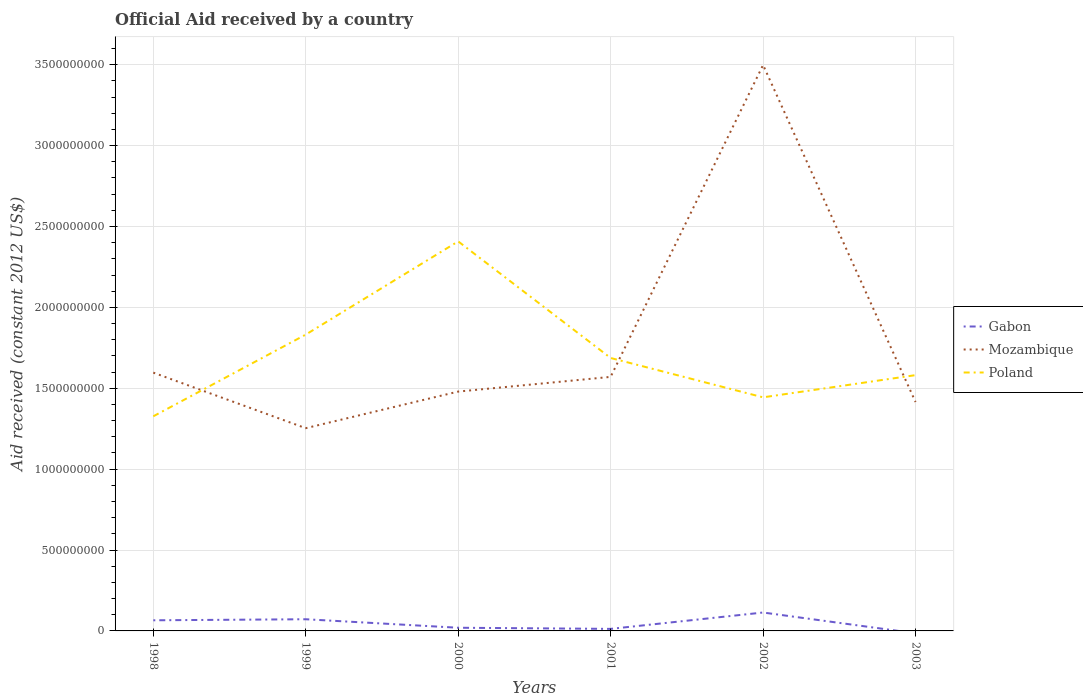Does the line corresponding to Gabon intersect with the line corresponding to Mozambique?
Give a very brief answer. No. Is the number of lines equal to the number of legend labels?
Ensure brevity in your answer.  No. Across all years, what is the maximum net official aid received in Poland?
Ensure brevity in your answer.  1.33e+09. What is the total net official aid received in Mozambique in the graph?
Your answer should be very brief. -1.90e+09. What is the difference between the highest and the second highest net official aid received in Gabon?
Ensure brevity in your answer.  1.14e+08. What is the difference between the highest and the lowest net official aid received in Poland?
Provide a succinct answer. 2. How many years are there in the graph?
Keep it short and to the point. 6. What is the difference between two consecutive major ticks on the Y-axis?
Ensure brevity in your answer.  5.00e+08. Are the values on the major ticks of Y-axis written in scientific E-notation?
Keep it short and to the point. No. Does the graph contain grids?
Provide a succinct answer. Yes. Where does the legend appear in the graph?
Offer a very short reply. Center right. What is the title of the graph?
Make the answer very short. Official Aid received by a country. What is the label or title of the X-axis?
Ensure brevity in your answer.  Years. What is the label or title of the Y-axis?
Make the answer very short. Aid received (constant 2012 US$). What is the Aid received (constant 2012 US$) in Gabon in 1998?
Your response must be concise. 6.57e+07. What is the Aid received (constant 2012 US$) of Mozambique in 1998?
Your answer should be very brief. 1.60e+09. What is the Aid received (constant 2012 US$) of Poland in 1998?
Offer a terse response. 1.33e+09. What is the Aid received (constant 2012 US$) of Gabon in 1999?
Keep it short and to the point. 7.22e+07. What is the Aid received (constant 2012 US$) of Mozambique in 1999?
Ensure brevity in your answer.  1.25e+09. What is the Aid received (constant 2012 US$) in Poland in 1999?
Your answer should be compact. 1.83e+09. What is the Aid received (constant 2012 US$) of Gabon in 2000?
Provide a short and direct response. 1.96e+07. What is the Aid received (constant 2012 US$) in Mozambique in 2000?
Give a very brief answer. 1.48e+09. What is the Aid received (constant 2012 US$) in Poland in 2000?
Your response must be concise. 2.41e+09. What is the Aid received (constant 2012 US$) of Gabon in 2001?
Provide a succinct answer. 1.26e+07. What is the Aid received (constant 2012 US$) in Mozambique in 2001?
Your answer should be very brief. 1.57e+09. What is the Aid received (constant 2012 US$) of Poland in 2001?
Your answer should be compact. 1.69e+09. What is the Aid received (constant 2012 US$) of Gabon in 2002?
Your answer should be very brief. 1.14e+08. What is the Aid received (constant 2012 US$) of Mozambique in 2002?
Offer a very short reply. 3.50e+09. What is the Aid received (constant 2012 US$) of Poland in 2002?
Ensure brevity in your answer.  1.44e+09. What is the Aid received (constant 2012 US$) of Mozambique in 2003?
Keep it short and to the point. 1.42e+09. What is the Aid received (constant 2012 US$) in Poland in 2003?
Your answer should be compact. 1.58e+09. Across all years, what is the maximum Aid received (constant 2012 US$) of Gabon?
Provide a short and direct response. 1.14e+08. Across all years, what is the maximum Aid received (constant 2012 US$) in Mozambique?
Give a very brief answer. 3.50e+09. Across all years, what is the maximum Aid received (constant 2012 US$) of Poland?
Ensure brevity in your answer.  2.41e+09. Across all years, what is the minimum Aid received (constant 2012 US$) in Gabon?
Provide a succinct answer. 0. Across all years, what is the minimum Aid received (constant 2012 US$) in Mozambique?
Your response must be concise. 1.25e+09. Across all years, what is the minimum Aid received (constant 2012 US$) in Poland?
Keep it short and to the point. 1.33e+09. What is the total Aid received (constant 2012 US$) in Gabon in the graph?
Offer a very short reply. 2.84e+08. What is the total Aid received (constant 2012 US$) of Mozambique in the graph?
Keep it short and to the point. 1.08e+1. What is the total Aid received (constant 2012 US$) in Poland in the graph?
Your answer should be compact. 1.03e+1. What is the difference between the Aid received (constant 2012 US$) in Gabon in 1998 and that in 1999?
Give a very brief answer. -6.49e+06. What is the difference between the Aid received (constant 2012 US$) of Mozambique in 1998 and that in 1999?
Provide a short and direct response. 3.43e+08. What is the difference between the Aid received (constant 2012 US$) of Poland in 1998 and that in 1999?
Your answer should be very brief. -5.05e+08. What is the difference between the Aid received (constant 2012 US$) of Gabon in 1998 and that in 2000?
Provide a succinct answer. 4.61e+07. What is the difference between the Aid received (constant 2012 US$) of Mozambique in 1998 and that in 2000?
Offer a terse response. 1.17e+08. What is the difference between the Aid received (constant 2012 US$) in Poland in 1998 and that in 2000?
Provide a succinct answer. -1.08e+09. What is the difference between the Aid received (constant 2012 US$) of Gabon in 1998 and that in 2001?
Provide a succinct answer. 5.31e+07. What is the difference between the Aid received (constant 2012 US$) in Mozambique in 1998 and that in 2001?
Your answer should be compact. 2.62e+07. What is the difference between the Aid received (constant 2012 US$) in Poland in 1998 and that in 2001?
Give a very brief answer. -3.60e+08. What is the difference between the Aid received (constant 2012 US$) of Gabon in 1998 and that in 2002?
Your response must be concise. -4.81e+07. What is the difference between the Aid received (constant 2012 US$) in Mozambique in 1998 and that in 2002?
Your answer should be compact. -1.90e+09. What is the difference between the Aid received (constant 2012 US$) in Poland in 1998 and that in 2002?
Provide a succinct answer. -1.17e+08. What is the difference between the Aid received (constant 2012 US$) in Mozambique in 1998 and that in 2003?
Make the answer very short. 1.82e+08. What is the difference between the Aid received (constant 2012 US$) of Poland in 1998 and that in 2003?
Keep it short and to the point. -2.55e+08. What is the difference between the Aid received (constant 2012 US$) of Gabon in 1999 and that in 2000?
Provide a short and direct response. 5.26e+07. What is the difference between the Aid received (constant 2012 US$) in Mozambique in 1999 and that in 2000?
Give a very brief answer. -2.26e+08. What is the difference between the Aid received (constant 2012 US$) in Poland in 1999 and that in 2000?
Offer a very short reply. -5.76e+08. What is the difference between the Aid received (constant 2012 US$) in Gabon in 1999 and that in 2001?
Offer a terse response. 5.96e+07. What is the difference between the Aid received (constant 2012 US$) of Mozambique in 1999 and that in 2001?
Give a very brief answer. -3.17e+08. What is the difference between the Aid received (constant 2012 US$) in Poland in 1999 and that in 2001?
Your answer should be very brief. 1.45e+08. What is the difference between the Aid received (constant 2012 US$) in Gabon in 1999 and that in 2002?
Provide a succinct answer. -4.16e+07. What is the difference between the Aid received (constant 2012 US$) of Mozambique in 1999 and that in 2002?
Your answer should be very brief. -2.25e+09. What is the difference between the Aid received (constant 2012 US$) in Poland in 1999 and that in 2002?
Give a very brief answer. 3.88e+08. What is the difference between the Aid received (constant 2012 US$) in Mozambique in 1999 and that in 2003?
Give a very brief answer. -1.62e+08. What is the difference between the Aid received (constant 2012 US$) of Poland in 1999 and that in 2003?
Provide a succinct answer. 2.51e+08. What is the difference between the Aid received (constant 2012 US$) of Mozambique in 2000 and that in 2001?
Provide a succinct answer. -9.08e+07. What is the difference between the Aid received (constant 2012 US$) of Poland in 2000 and that in 2001?
Provide a short and direct response. 7.21e+08. What is the difference between the Aid received (constant 2012 US$) of Gabon in 2000 and that in 2002?
Make the answer very short. -9.42e+07. What is the difference between the Aid received (constant 2012 US$) of Mozambique in 2000 and that in 2002?
Provide a succinct answer. -2.02e+09. What is the difference between the Aid received (constant 2012 US$) of Poland in 2000 and that in 2002?
Give a very brief answer. 9.64e+08. What is the difference between the Aid received (constant 2012 US$) of Mozambique in 2000 and that in 2003?
Ensure brevity in your answer.  6.45e+07. What is the difference between the Aid received (constant 2012 US$) of Poland in 2000 and that in 2003?
Your response must be concise. 8.27e+08. What is the difference between the Aid received (constant 2012 US$) in Gabon in 2001 and that in 2002?
Make the answer very short. -1.01e+08. What is the difference between the Aid received (constant 2012 US$) in Mozambique in 2001 and that in 2002?
Offer a terse response. -1.93e+09. What is the difference between the Aid received (constant 2012 US$) of Poland in 2001 and that in 2002?
Give a very brief answer. 2.43e+08. What is the difference between the Aid received (constant 2012 US$) in Mozambique in 2001 and that in 2003?
Your answer should be compact. 1.55e+08. What is the difference between the Aid received (constant 2012 US$) of Poland in 2001 and that in 2003?
Offer a terse response. 1.06e+08. What is the difference between the Aid received (constant 2012 US$) of Mozambique in 2002 and that in 2003?
Your answer should be compact. 2.08e+09. What is the difference between the Aid received (constant 2012 US$) of Poland in 2002 and that in 2003?
Give a very brief answer. -1.37e+08. What is the difference between the Aid received (constant 2012 US$) in Gabon in 1998 and the Aid received (constant 2012 US$) in Mozambique in 1999?
Offer a terse response. -1.19e+09. What is the difference between the Aid received (constant 2012 US$) of Gabon in 1998 and the Aid received (constant 2012 US$) of Poland in 1999?
Your response must be concise. -1.77e+09. What is the difference between the Aid received (constant 2012 US$) of Mozambique in 1998 and the Aid received (constant 2012 US$) of Poland in 1999?
Your response must be concise. -2.35e+08. What is the difference between the Aid received (constant 2012 US$) of Gabon in 1998 and the Aid received (constant 2012 US$) of Mozambique in 2000?
Your answer should be compact. -1.41e+09. What is the difference between the Aid received (constant 2012 US$) of Gabon in 1998 and the Aid received (constant 2012 US$) of Poland in 2000?
Offer a very short reply. -2.34e+09. What is the difference between the Aid received (constant 2012 US$) in Mozambique in 1998 and the Aid received (constant 2012 US$) in Poland in 2000?
Offer a very short reply. -8.11e+08. What is the difference between the Aid received (constant 2012 US$) of Gabon in 1998 and the Aid received (constant 2012 US$) of Mozambique in 2001?
Provide a succinct answer. -1.50e+09. What is the difference between the Aid received (constant 2012 US$) of Gabon in 1998 and the Aid received (constant 2012 US$) of Poland in 2001?
Your answer should be very brief. -1.62e+09. What is the difference between the Aid received (constant 2012 US$) in Mozambique in 1998 and the Aid received (constant 2012 US$) in Poland in 2001?
Keep it short and to the point. -9.05e+07. What is the difference between the Aid received (constant 2012 US$) in Gabon in 1998 and the Aid received (constant 2012 US$) in Mozambique in 2002?
Ensure brevity in your answer.  -3.43e+09. What is the difference between the Aid received (constant 2012 US$) in Gabon in 1998 and the Aid received (constant 2012 US$) in Poland in 2002?
Ensure brevity in your answer.  -1.38e+09. What is the difference between the Aid received (constant 2012 US$) in Mozambique in 1998 and the Aid received (constant 2012 US$) in Poland in 2002?
Give a very brief answer. 1.53e+08. What is the difference between the Aid received (constant 2012 US$) in Gabon in 1998 and the Aid received (constant 2012 US$) in Mozambique in 2003?
Offer a very short reply. -1.35e+09. What is the difference between the Aid received (constant 2012 US$) in Gabon in 1998 and the Aid received (constant 2012 US$) in Poland in 2003?
Keep it short and to the point. -1.52e+09. What is the difference between the Aid received (constant 2012 US$) of Mozambique in 1998 and the Aid received (constant 2012 US$) of Poland in 2003?
Your answer should be very brief. 1.54e+07. What is the difference between the Aid received (constant 2012 US$) of Gabon in 1999 and the Aid received (constant 2012 US$) of Mozambique in 2000?
Offer a very short reply. -1.41e+09. What is the difference between the Aid received (constant 2012 US$) in Gabon in 1999 and the Aid received (constant 2012 US$) in Poland in 2000?
Ensure brevity in your answer.  -2.34e+09. What is the difference between the Aid received (constant 2012 US$) of Mozambique in 1999 and the Aid received (constant 2012 US$) of Poland in 2000?
Your answer should be very brief. -1.15e+09. What is the difference between the Aid received (constant 2012 US$) in Gabon in 1999 and the Aid received (constant 2012 US$) in Mozambique in 2001?
Provide a short and direct response. -1.50e+09. What is the difference between the Aid received (constant 2012 US$) in Gabon in 1999 and the Aid received (constant 2012 US$) in Poland in 2001?
Offer a terse response. -1.61e+09. What is the difference between the Aid received (constant 2012 US$) in Mozambique in 1999 and the Aid received (constant 2012 US$) in Poland in 2001?
Offer a terse response. -4.34e+08. What is the difference between the Aid received (constant 2012 US$) of Gabon in 1999 and the Aid received (constant 2012 US$) of Mozambique in 2002?
Provide a succinct answer. -3.43e+09. What is the difference between the Aid received (constant 2012 US$) of Gabon in 1999 and the Aid received (constant 2012 US$) of Poland in 2002?
Your answer should be compact. -1.37e+09. What is the difference between the Aid received (constant 2012 US$) of Mozambique in 1999 and the Aid received (constant 2012 US$) of Poland in 2002?
Make the answer very short. -1.91e+08. What is the difference between the Aid received (constant 2012 US$) in Gabon in 1999 and the Aid received (constant 2012 US$) in Mozambique in 2003?
Offer a very short reply. -1.34e+09. What is the difference between the Aid received (constant 2012 US$) of Gabon in 1999 and the Aid received (constant 2012 US$) of Poland in 2003?
Give a very brief answer. -1.51e+09. What is the difference between the Aid received (constant 2012 US$) in Mozambique in 1999 and the Aid received (constant 2012 US$) in Poland in 2003?
Offer a very short reply. -3.28e+08. What is the difference between the Aid received (constant 2012 US$) in Gabon in 2000 and the Aid received (constant 2012 US$) in Mozambique in 2001?
Provide a short and direct response. -1.55e+09. What is the difference between the Aid received (constant 2012 US$) in Gabon in 2000 and the Aid received (constant 2012 US$) in Poland in 2001?
Your answer should be compact. -1.67e+09. What is the difference between the Aid received (constant 2012 US$) in Mozambique in 2000 and the Aid received (constant 2012 US$) in Poland in 2001?
Your answer should be very brief. -2.08e+08. What is the difference between the Aid received (constant 2012 US$) in Gabon in 2000 and the Aid received (constant 2012 US$) in Mozambique in 2002?
Make the answer very short. -3.48e+09. What is the difference between the Aid received (constant 2012 US$) in Gabon in 2000 and the Aid received (constant 2012 US$) in Poland in 2002?
Your answer should be very brief. -1.42e+09. What is the difference between the Aid received (constant 2012 US$) of Mozambique in 2000 and the Aid received (constant 2012 US$) of Poland in 2002?
Your answer should be very brief. 3.56e+07. What is the difference between the Aid received (constant 2012 US$) of Gabon in 2000 and the Aid received (constant 2012 US$) of Mozambique in 2003?
Provide a short and direct response. -1.40e+09. What is the difference between the Aid received (constant 2012 US$) of Gabon in 2000 and the Aid received (constant 2012 US$) of Poland in 2003?
Provide a short and direct response. -1.56e+09. What is the difference between the Aid received (constant 2012 US$) in Mozambique in 2000 and the Aid received (constant 2012 US$) in Poland in 2003?
Your response must be concise. -1.02e+08. What is the difference between the Aid received (constant 2012 US$) of Gabon in 2001 and the Aid received (constant 2012 US$) of Mozambique in 2002?
Offer a terse response. -3.49e+09. What is the difference between the Aid received (constant 2012 US$) of Gabon in 2001 and the Aid received (constant 2012 US$) of Poland in 2002?
Provide a short and direct response. -1.43e+09. What is the difference between the Aid received (constant 2012 US$) in Mozambique in 2001 and the Aid received (constant 2012 US$) in Poland in 2002?
Ensure brevity in your answer.  1.26e+08. What is the difference between the Aid received (constant 2012 US$) of Gabon in 2001 and the Aid received (constant 2012 US$) of Mozambique in 2003?
Make the answer very short. -1.40e+09. What is the difference between the Aid received (constant 2012 US$) in Gabon in 2001 and the Aid received (constant 2012 US$) in Poland in 2003?
Your answer should be very brief. -1.57e+09. What is the difference between the Aid received (constant 2012 US$) in Mozambique in 2001 and the Aid received (constant 2012 US$) in Poland in 2003?
Give a very brief answer. -1.08e+07. What is the difference between the Aid received (constant 2012 US$) in Gabon in 2002 and the Aid received (constant 2012 US$) in Mozambique in 2003?
Your response must be concise. -1.30e+09. What is the difference between the Aid received (constant 2012 US$) of Gabon in 2002 and the Aid received (constant 2012 US$) of Poland in 2003?
Your answer should be compact. -1.47e+09. What is the difference between the Aid received (constant 2012 US$) of Mozambique in 2002 and the Aid received (constant 2012 US$) of Poland in 2003?
Offer a very short reply. 1.92e+09. What is the average Aid received (constant 2012 US$) of Gabon per year?
Provide a short and direct response. 4.73e+07. What is the average Aid received (constant 2012 US$) of Mozambique per year?
Your response must be concise. 1.80e+09. What is the average Aid received (constant 2012 US$) in Poland per year?
Your answer should be compact. 1.71e+09. In the year 1998, what is the difference between the Aid received (constant 2012 US$) in Gabon and Aid received (constant 2012 US$) in Mozambique?
Offer a very short reply. -1.53e+09. In the year 1998, what is the difference between the Aid received (constant 2012 US$) in Gabon and Aid received (constant 2012 US$) in Poland?
Provide a short and direct response. -1.26e+09. In the year 1998, what is the difference between the Aid received (constant 2012 US$) of Mozambique and Aid received (constant 2012 US$) of Poland?
Ensure brevity in your answer.  2.70e+08. In the year 1999, what is the difference between the Aid received (constant 2012 US$) in Gabon and Aid received (constant 2012 US$) in Mozambique?
Provide a succinct answer. -1.18e+09. In the year 1999, what is the difference between the Aid received (constant 2012 US$) of Gabon and Aid received (constant 2012 US$) of Poland?
Provide a succinct answer. -1.76e+09. In the year 1999, what is the difference between the Aid received (constant 2012 US$) of Mozambique and Aid received (constant 2012 US$) of Poland?
Your answer should be compact. -5.78e+08. In the year 2000, what is the difference between the Aid received (constant 2012 US$) of Gabon and Aid received (constant 2012 US$) of Mozambique?
Your response must be concise. -1.46e+09. In the year 2000, what is the difference between the Aid received (constant 2012 US$) in Gabon and Aid received (constant 2012 US$) in Poland?
Make the answer very short. -2.39e+09. In the year 2000, what is the difference between the Aid received (constant 2012 US$) in Mozambique and Aid received (constant 2012 US$) in Poland?
Your answer should be very brief. -9.28e+08. In the year 2001, what is the difference between the Aid received (constant 2012 US$) in Gabon and Aid received (constant 2012 US$) in Mozambique?
Provide a short and direct response. -1.56e+09. In the year 2001, what is the difference between the Aid received (constant 2012 US$) in Gabon and Aid received (constant 2012 US$) in Poland?
Provide a short and direct response. -1.67e+09. In the year 2001, what is the difference between the Aid received (constant 2012 US$) in Mozambique and Aid received (constant 2012 US$) in Poland?
Your answer should be compact. -1.17e+08. In the year 2002, what is the difference between the Aid received (constant 2012 US$) of Gabon and Aid received (constant 2012 US$) of Mozambique?
Offer a very short reply. -3.38e+09. In the year 2002, what is the difference between the Aid received (constant 2012 US$) in Gabon and Aid received (constant 2012 US$) in Poland?
Your response must be concise. -1.33e+09. In the year 2002, what is the difference between the Aid received (constant 2012 US$) of Mozambique and Aid received (constant 2012 US$) of Poland?
Your answer should be very brief. 2.05e+09. In the year 2003, what is the difference between the Aid received (constant 2012 US$) in Mozambique and Aid received (constant 2012 US$) in Poland?
Provide a succinct answer. -1.66e+08. What is the ratio of the Aid received (constant 2012 US$) in Gabon in 1998 to that in 1999?
Give a very brief answer. 0.91. What is the ratio of the Aid received (constant 2012 US$) in Mozambique in 1998 to that in 1999?
Keep it short and to the point. 1.27. What is the ratio of the Aid received (constant 2012 US$) of Poland in 1998 to that in 1999?
Your answer should be compact. 0.72. What is the ratio of the Aid received (constant 2012 US$) of Gabon in 1998 to that in 2000?
Provide a short and direct response. 3.35. What is the ratio of the Aid received (constant 2012 US$) in Mozambique in 1998 to that in 2000?
Your answer should be very brief. 1.08. What is the ratio of the Aid received (constant 2012 US$) of Poland in 1998 to that in 2000?
Your answer should be very brief. 0.55. What is the ratio of the Aid received (constant 2012 US$) of Gabon in 1998 to that in 2001?
Provide a succinct answer. 5.21. What is the ratio of the Aid received (constant 2012 US$) in Mozambique in 1998 to that in 2001?
Provide a short and direct response. 1.02. What is the ratio of the Aid received (constant 2012 US$) of Poland in 1998 to that in 2001?
Give a very brief answer. 0.79. What is the ratio of the Aid received (constant 2012 US$) in Gabon in 1998 to that in 2002?
Give a very brief answer. 0.58. What is the ratio of the Aid received (constant 2012 US$) of Mozambique in 1998 to that in 2002?
Ensure brevity in your answer.  0.46. What is the ratio of the Aid received (constant 2012 US$) in Poland in 1998 to that in 2002?
Offer a very short reply. 0.92. What is the ratio of the Aid received (constant 2012 US$) of Mozambique in 1998 to that in 2003?
Your answer should be compact. 1.13. What is the ratio of the Aid received (constant 2012 US$) in Poland in 1998 to that in 2003?
Your answer should be very brief. 0.84. What is the ratio of the Aid received (constant 2012 US$) in Gabon in 1999 to that in 2000?
Your response must be concise. 3.68. What is the ratio of the Aid received (constant 2012 US$) in Mozambique in 1999 to that in 2000?
Provide a short and direct response. 0.85. What is the ratio of the Aid received (constant 2012 US$) of Poland in 1999 to that in 2000?
Keep it short and to the point. 0.76. What is the ratio of the Aid received (constant 2012 US$) in Gabon in 1999 to that in 2001?
Ensure brevity in your answer.  5.72. What is the ratio of the Aid received (constant 2012 US$) in Mozambique in 1999 to that in 2001?
Give a very brief answer. 0.8. What is the ratio of the Aid received (constant 2012 US$) in Poland in 1999 to that in 2001?
Your response must be concise. 1.09. What is the ratio of the Aid received (constant 2012 US$) in Gabon in 1999 to that in 2002?
Ensure brevity in your answer.  0.63. What is the ratio of the Aid received (constant 2012 US$) of Mozambique in 1999 to that in 2002?
Offer a terse response. 0.36. What is the ratio of the Aid received (constant 2012 US$) in Poland in 1999 to that in 2002?
Provide a succinct answer. 1.27. What is the ratio of the Aid received (constant 2012 US$) in Mozambique in 1999 to that in 2003?
Provide a short and direct response. 0.89. What is the ratio of the Aid received (constant 2012 US$) in Poland in 1999 to that in 2003?
Give a very brief answer. 1.16. What is the ratio of the Aid received (constant 2012 US$) of Gabon in 2000 to that in 2001?
Give a very brief answer. 1.55. What is the ratio of the Aid received (constant 2012 US$) of Mozambique in 2000 to that in 2001?
Your answer should be very brief. 0.94. What is the ratio of the Aid received (constant 2012 US$) in Poland in 2000 to that in 2001?
Your answer should be compact. 1.43. What is the ratio of the Aid received (constant 2012 US$) in Gabon in 2000 to that in 2002?
Make the answer very short. 0.17. What is the ratio of the Aid received (constant 2012 US$) of Mozambique in 2000 to that in 2002?
Offer a terse response. 0.42. What is the ratio of the Aid received (constant 2012 US$) in Poland in 2000 to that in 2002?
Your response must be concise. 1.67. What is the ratio of the Aid received (constant 2012 US$) in Mozambique in 2000 to that in 2003?
Provide a succinct answer. 1.05. What is the ratio of the Aid received (constant 2012 US$) in Poland in 2000 to that in 2003?
Your response must be concise. 1.52. What is the ratio of the Aid received (constant 2012 US$) in Gabon in 2001 to that in 2002?
Your response must be concise. 0.11. What is the ratio of the Aid received (constant 2012 US$) of Mozambique in 2001 to that in 2002?
Your response must be concise. 0.45. What is the ratio of the Aid received (constant 2012 US$) of Poland in 2001 to that in 2002?
Give a very brief answer. 1.17. What is the ratio of the Aid received (constant 2012 US$) in Mozambique in 2001 to that in 2003?
Offer a terse response. 1.11. What is the ratio of the Aid received (constant 2012 US$) in Poland in 2001 to that in 2003?
Give a very brief answer. 1.07. What is the ratio of the Aid received (constant 2012 US$) in Mozambique in 2002 to that in 2003?
Give a very brief answer. 2.47. What is the ratio of the Aid received (constant 2012 US$) in Poland in 2002 to that in 2003?
Your response must be concise. 0.91. What is the difference between the highest and the second highest Aid received (constant 2012 US$) of Gabon?
Offer a very short reply. 4.16e+07. What is the difference between the highest and the second highest Aid received (constant 2012 US$) of Mozambique?
Your response must be concise. 1.90e+09. What is the difference between the highest and the second highest Aid received (constant 2012 US$) in Poland?
Make the answer very short. 5.76e+08. What is the difference between the highest and the lowest Aid received (constant 2012 US$) of Gabon?
Provide a succinct answer. 1.14e+08. What is the difference between the highest and the lowest Aid received (constant 2012 US$) in Mozambique?
Make the answer very short. 2.25e+09. What is the difference between the highest and the lowest Aid received (constant 2012 US$) of Poland?
Provide a short and direct response. 1.08e+09. 